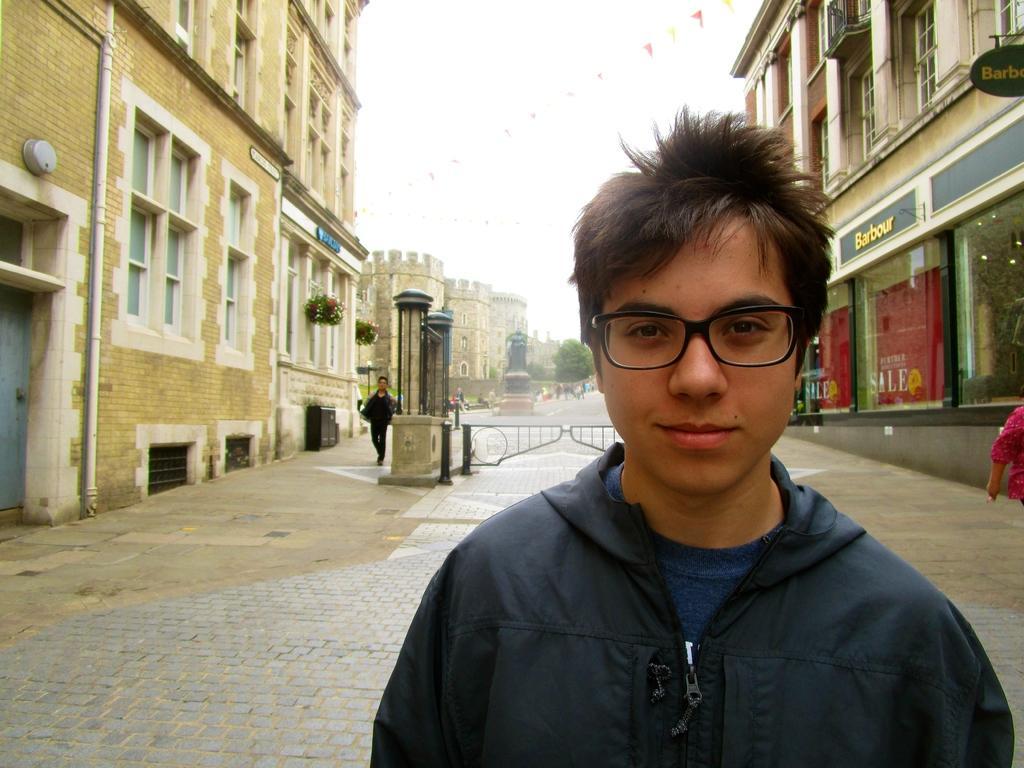How would you summarize this image in a sentence or two? In this image we can see persons walking on the road. In the background there are buildings, pipelines, doors, pillars, stores, sky and houseplants. 